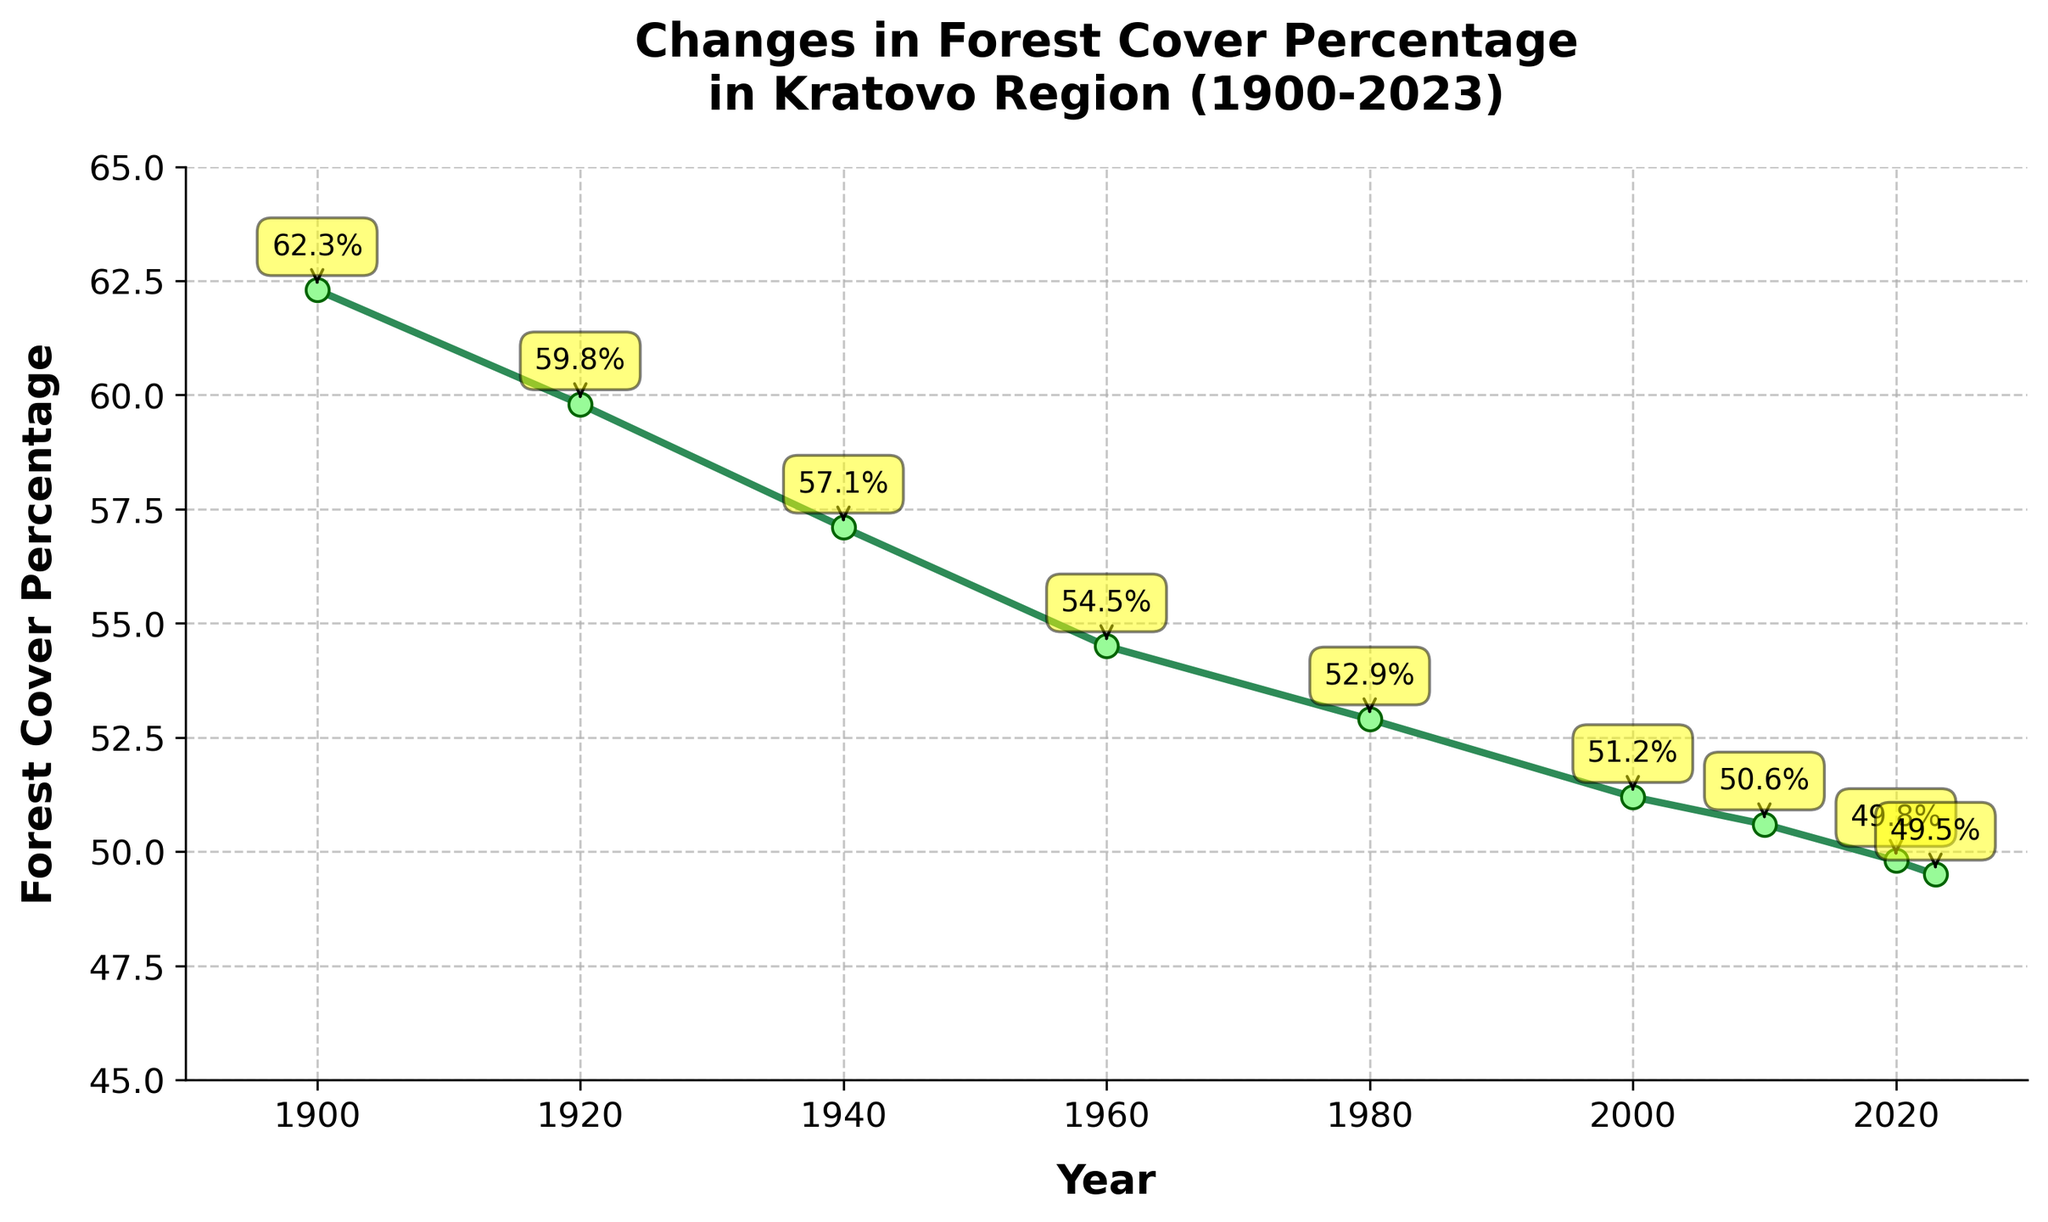What's the overall trend in forest cover percentage in Kratovo from 1900 to 2023? The plot shows a decreasing trend in forest cover percentage from 62.3% in 1900 to 49.5% in 2023, indicating continuous deforestation.
Answer: Decreasing trend In which two decades did the forest cover percentage decrease the most? From 1900 to 1940, the forest cover percentage decreased from 62.3% to 57.1%, and from 1940 to 1960, it further decreased to 54.5%. The first period (1900-1920) saw a drop of 2.5%, and the second period (1940-1960) saw a drop of 2.6%. Comparing all the periods, the two decades from 1940 to 1960 had the largest decrease.
Answer: 1940 to 1960 By how much did the forest cover percentage decline per year between 1900 and 2023? To calculate the average yearly decline, we subtract the 2023 value from the 1900 value and then divide by the number of years (2023 - 1900). This gives (62.3 - 49.5) / (2023 - 1900) = 12.8 / 123 ≈ 0.104%.
Answer: Approximately 0.104% Between 2000 and 2023, how did the forest cover change and was the rate of change faster or slower compared to the average rate between 1900 and 2023? The forest cover percentage declined from 51.2% in 2000 to 49.5% in 2023. This decline is 1.7% over 23 years, making an average yearly decline of 1.7 / 23 ≈ 0.074%. Comparing this to the overall average decline of approximately 0.104%, the rate of change between 2000 and 2023 is slower.
Answer: Slower What was the forest cover percentage in the middle of the 20th century, i.e., around 1950? From the plot, the closest data points to 1950 are for the years 1940 (57.1%) and 1960 (54.5%). By estimating the average of these two points: (57.1 + 54.5) / 2 ≈ 55.8%.
Answer: Approximately 55.8% At which point in time did the forest cover fall below 60% for the first time? According to the plot, the forest cover percentage was 62.3% in 1900 and fell to 59.8% in 1920, marking the first time it dropped below 60%.
Answer: 1920 What is the difference in forest cover percentage between 2000 and 2023? The forest cover percentage in 2000 is 51.2% and in 2023 is 49.5%. The difference is 51.2 - 49.5 = 1.7%.
Answer: 1.7% Compare the forest cover percentage between 1920 and 1960. Which year had a higher value and by how much? From the plot, the forest cover percentage in 1920 is 59.8% and in 1960 is 54.5%. 1920 had a higher value by 59.8 - 54.5 = 5.3%.
Answer: 1920 by 5.3% Which year on the plot shows the smallest decline in forest cover percentage compared to its previous data point? Compare the differences between each listed year and its preceding year. The smallest difference can be seen between 2010 and 2020, where the forest cover declined from 50.6% to 49.8%, a difference of 0.8%.
Answer: 2010-2020 What is the average forest cover percentage over the entire period displayed in the plot (1900-2023)? Sum the forest cover percentages and divide by the number of data points. (62.3 + 59.8 + 57.1 + 54.5 + 52.9 + 51.2 + 50.6 + 49.8 + 49.5) / 9 ≈ 54%.
Answer: 54% 